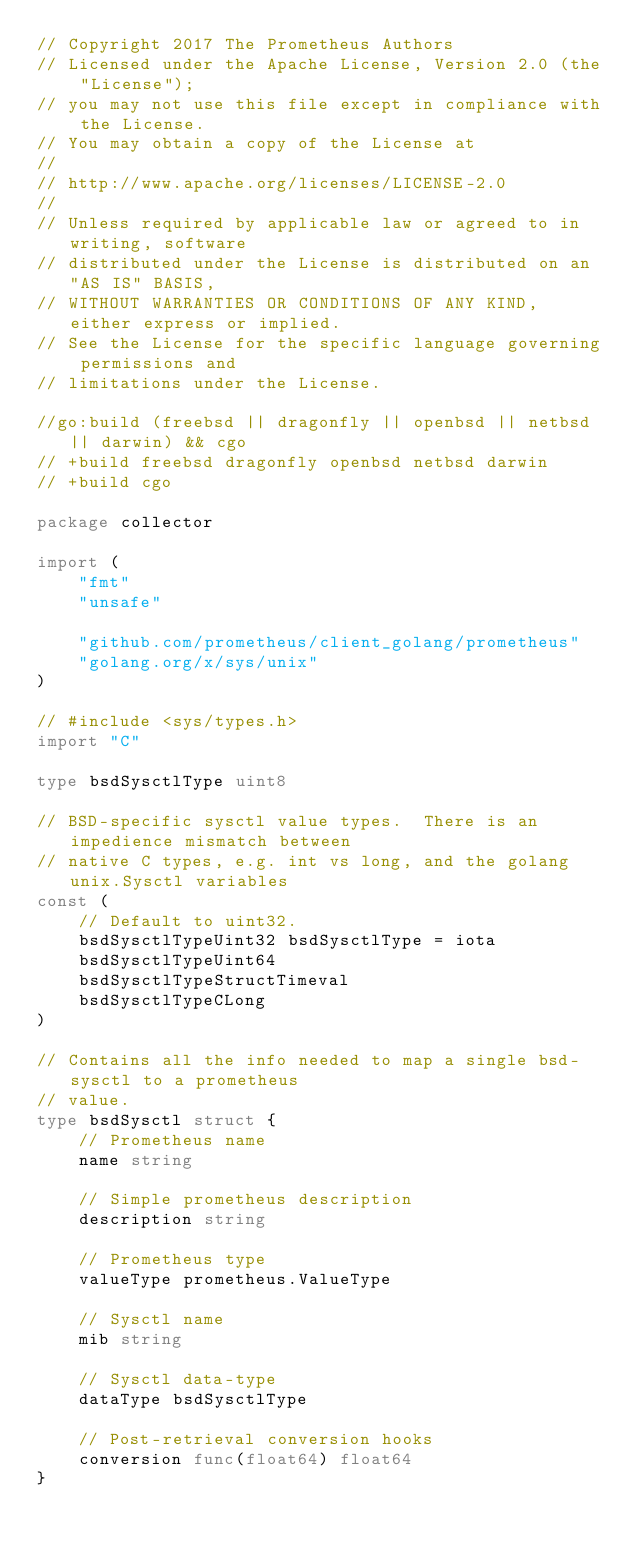<code> <loc_0><loc_0><loc_500><loc_500><_Go_>// Copyright 2017 The Prometheus Authors
// Licensed under the Apache License, Version 2.0 (the "License");
// you may not use this file except in compliance with the License.
// You may obtain a copy of the License at
//
// http://www.apache.org/licenses/LICENSE-2.0
//
// Unless required by applicable law or agreed to in writing, software
// distributed under the License is distributed on an "AS IS" BASIS,
// WITHOUT WARRANTIES OR CONDITIONS OF ANY KIND, either express or implied.
// See the License for the specific language governing permissions and
// limitations under the License.

//go:build (freebsd || dragonfly || openbsd || netbsd || darwin) && cgo
// +build freebsd dragonfly openbsd netbsd darwin
// +build cgo

package collector

import (
	"fmt"
	"unsafe"

	"github.com/prometheus/client_golang/prometheus"
	"golang.org/x/sys/unix"
)

// #include <sys/types.h>
import "C"

type bsdSysctlType uint8

// BSD-specific sysctl value types.  There is an impedience mismatch between
// native C types, e.g. int vs long, and the golang unix.Sysctl variables
const (
	// Default to uint32.
	bsdSysctlTypeUint32 bsdSysctlType = iota
	bsdSysctlTypeUint64
	bsdSysctlTypeStructTimeval
	bsdSysctlTypeCLong
)

// Contains all the info needed to map a single bsd-sysctl to a prometheus
// value.
type bsdSysctl struct {
	// Prometheus name
	name string

	// Simple prometheus description
	description string

	// Prometheus type
	valueType prometheus.ValueType

	// Sysctl name
	mib string

	// Sysctl data-type
	dataType bsdSysctlType

	// Post-retrieval conversion hooks
	conversion func(float64) float64
}
</code> 